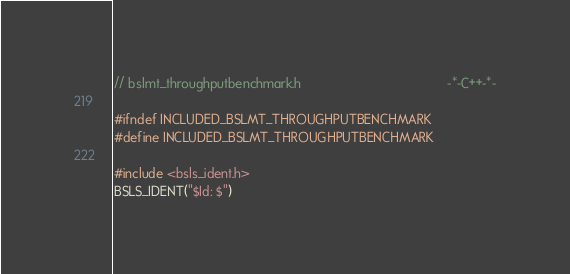<code> <loc_0><loc_0><loc_500><loc_500><_C_>// bslmt_throughputbenchmark.h                                        -*-C++-*-

#ifndef INCLUDED_BSLMT_THROUGHPUTBENCHMARK
#define INCLUDED_BSLMT_THROUGHPUTBENCHMARK

#include <bsls_ident.h>
BSLS_IDENT("$Id: $")
</code> 